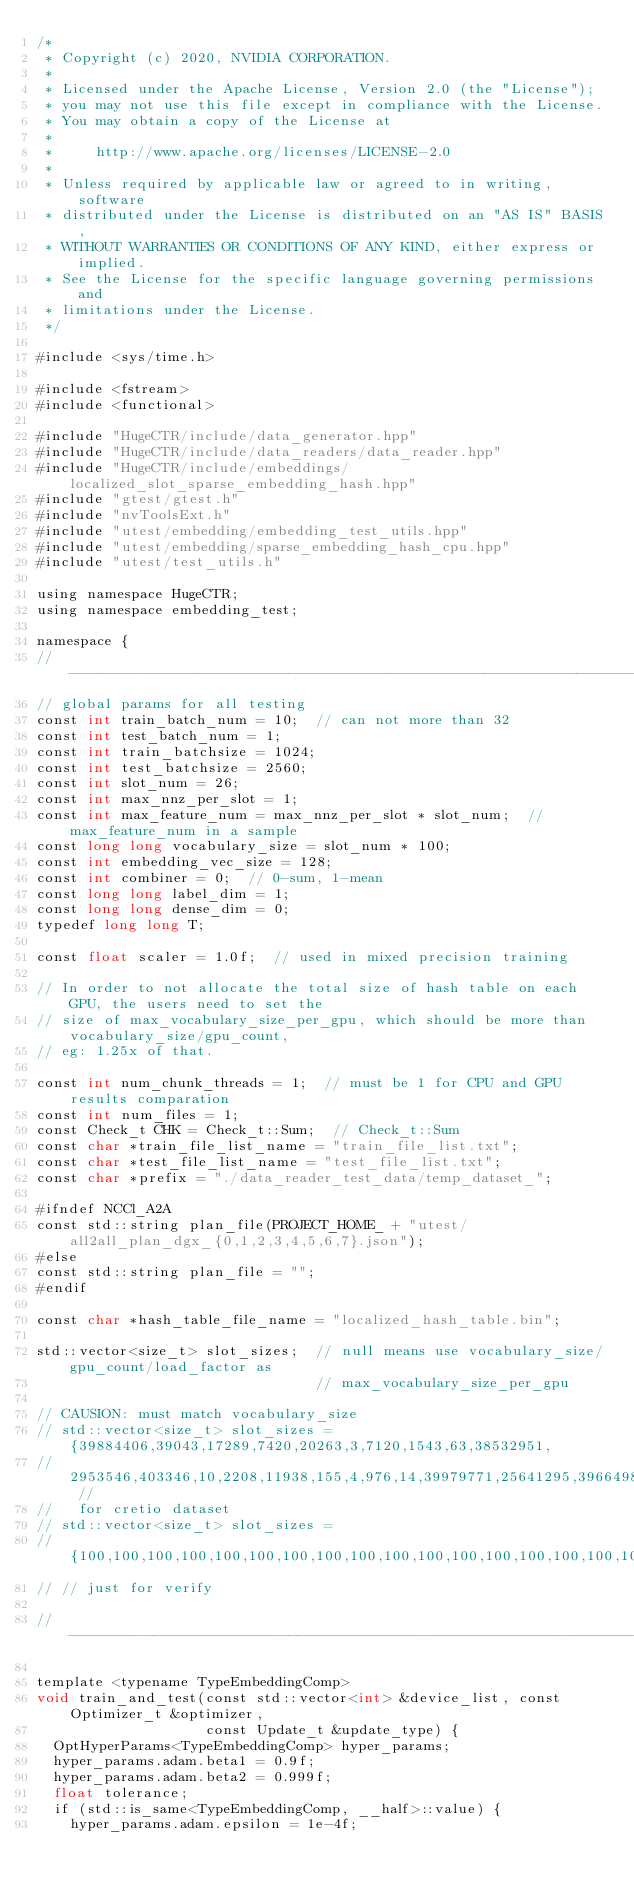Convert code to text. <code><loc_0><loc_0><loc_500><loc_500><_Cuda_>/*
 * Copyright (c) 2020, NVIDIA CORPORATION.
 *
 * Licensed under the Apache License, Version 2.0 (the "License");
 * you may not use this file except in compliance with the License.
 * You may obtain a copy of the License at
 *
 *     http://www.apache.org/licenses/LICENSE-2.0
 *
 * Unless required by applicable law or agreed to in writing, software
 * distributed under the License is distributed on an "AS IS" BASIS,
 * WITHOUT WARRANTIES OR CONDITIONS OF ANY KIND, either express or implied.
 * See the License for the specific language governing permissions and
 * limitations under the License.
 */

#include <sys/time.h>

#include <fstream>
#include <functional>

#include "HugeCTR/include/data_generator.hpp"
#include "HugeCTR/include/data_readers/data_reader.hpp"
#include "HugeCTR/include/embeddings/localized_slot_sparse_embedding_hash.hpp"
#include "gtest/gtest.h"
#include "nvToolsExt.h"
#include "utest/embedding/embedding_test_utils.hpp"
#include "utest/embedding/sparse_embedding_hash_cpu.hpp"
#include "utest/test_utils.h"

using namespace HugeCTR;
using namespace embedding_test;

namespace {
//---------------------------------------------------------------------------------------
// global params for all testing
const int train_batch_num = 10;  // can not more than 32
const int test_batch_num = 1;
const int train_batchsize = 1024;
const int test_batchsize = 2560;
const int slot_num = 26;
const int max_nnz_per_slot = 1;
const int max_feature_num = max_nnz_per_slot * slot_num;  // max_feature_num in a sample
const long long vocabulary_size = slot_num * 100;
const int embedding_vec_size = 128;
const int combiner = 0;  // 0-sum, 1-mean
const long long label_dim = 1;
const long long dense_dim = 0;
typedef long long T;

const float scaler = 1.0f;  // used in mixed precision training

// In order to not allocate the total size of hash table on each GPU, the users need to set the
// size of max_vocabulary_size_per_gpu, which should be more than vocabulary_size/gpu_count,
// eg: 1.25x of that.

const int num_chunk_threads = 1;  // must be 1 for CPU and GPU results comparation
const int num_files = 1;
const Check_t CHK = Check_t::Sum;  // Check_t::Sum
const char *train_file_list_name = "train_file_list.txt";
const char *test_file_list_name = "test_file_list.txt";
const char *prefix = "./data_reader_test_data/temp_dataset_";

#ifndef NCCl_A2A
const std::string plan_file(PROJECT_HOME_ + "utest/all2all_plan_dgx_{0,1,2,3,4,5,6,7}.json");
#else
const std::string plan_file = "";
#endif

const char *hash_table_file_name = "localized_hash_table.bin";

std::vector<size_t> slot_sizes;  // null means use vocabulary_size/gpu_count/load_factor as
                                 // max_vocabulary_size_per_gpu

// CAUSION: must match vocabulary_size
// std::vector<size_t> slot_sizes = {39884406,39043,17289,7420,20263,3,7120,1543,63,38532951,
//   2953546,403346,10,2208,11938,155,4,976,14,39979771,25641295,39664984,585935,12972,108,36}; //
//   for cretio dataset
// std::vector<size_t> slot_sizes =
// {100,100,100,100,100,100,100,100,100,100,100,100,100,100,100,100,100,100,100,100,100,100,100,100,100,100};
// // just for verify

//-----------------------------------------------------------------------------------------

template <typename TypeEmbeddingComp>
void train_and_test(const std::vector<int> &device_list, const Optimizer_t &optimizer,
                    const Update_t &update_type) {
  OptHyperParams<TypeEmbeddingComp> hyper_params;
  hyper_params.adam.beta1 = 0.9f;
  hyper_params.adam.beta2 = 0.999f;
  float tolerance;
  if (std::is_same<TypeEmbeddingComp, __half>::value) {
    hyper_params.adam.epsilon = 1e-4f;</code> 